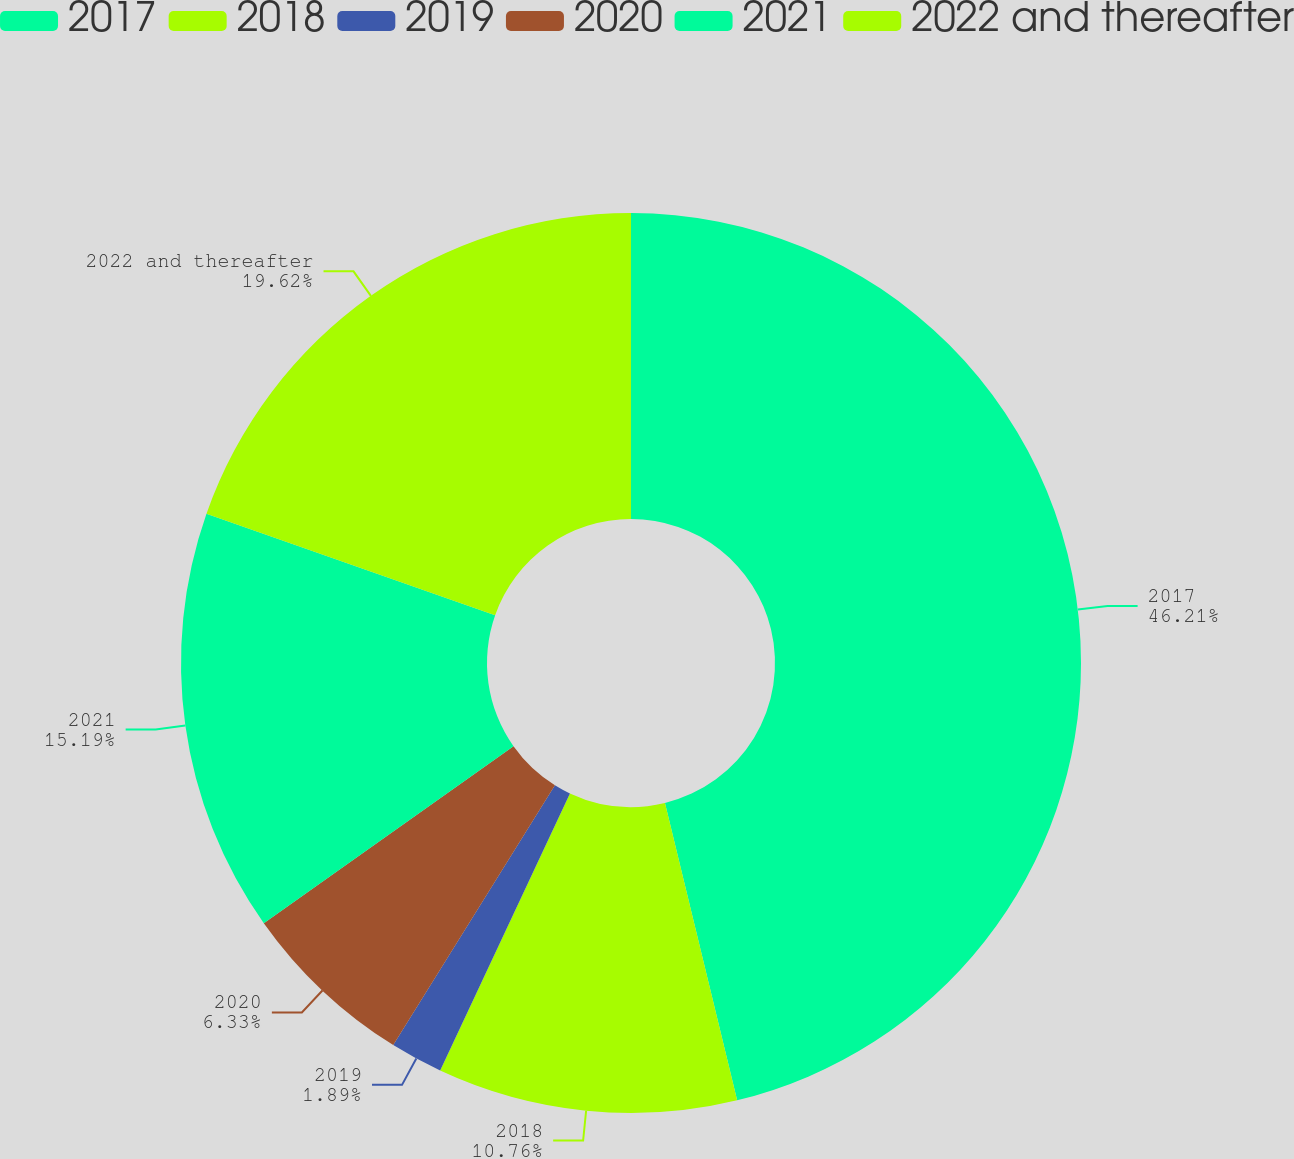<chart> <loc_0><loc_0><loc_500><loc_500><pie_chart><fcel>2017<fcel>2018<fcel>2019<fcel>2020<fcel>2021<fcel>2022 and thereafter<nl><fcel>46.21%<fcel>10.76%<fcel>1.89%<fcel>6.33%<fcel>15.19%<fcel>19.62%<nl></chart> 